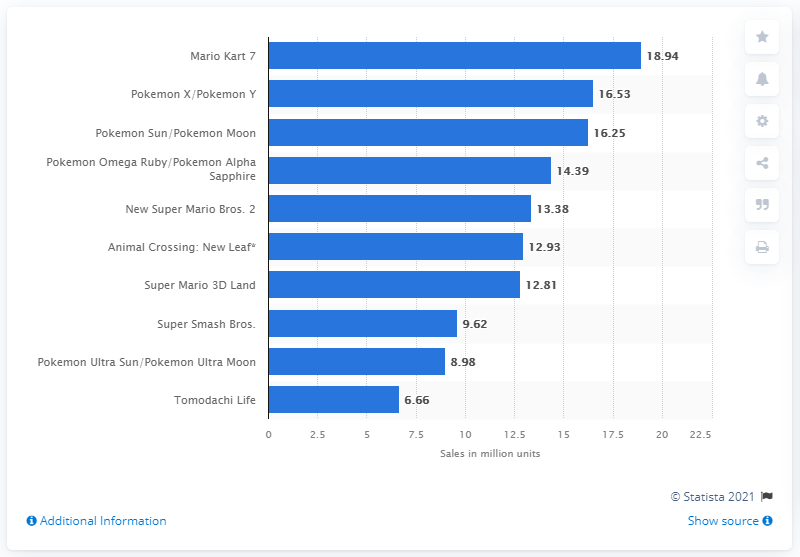Give some essential details in this illustration. In Mario Kart 7, a total of 18,940 units were sold worldwide. As of March 2021, Mario Kart 7 was the top-selling Nintendo 3DS game. 